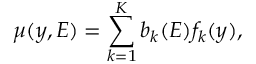Convert formula to latex. <formula><loc_0><loc_0><loc_500><loc_500>\mu ( y , E ) = \sum _ { k = 1 } ^ { K } b _ { k } ( E ) f _ { k } ( y ) ,</formula> 